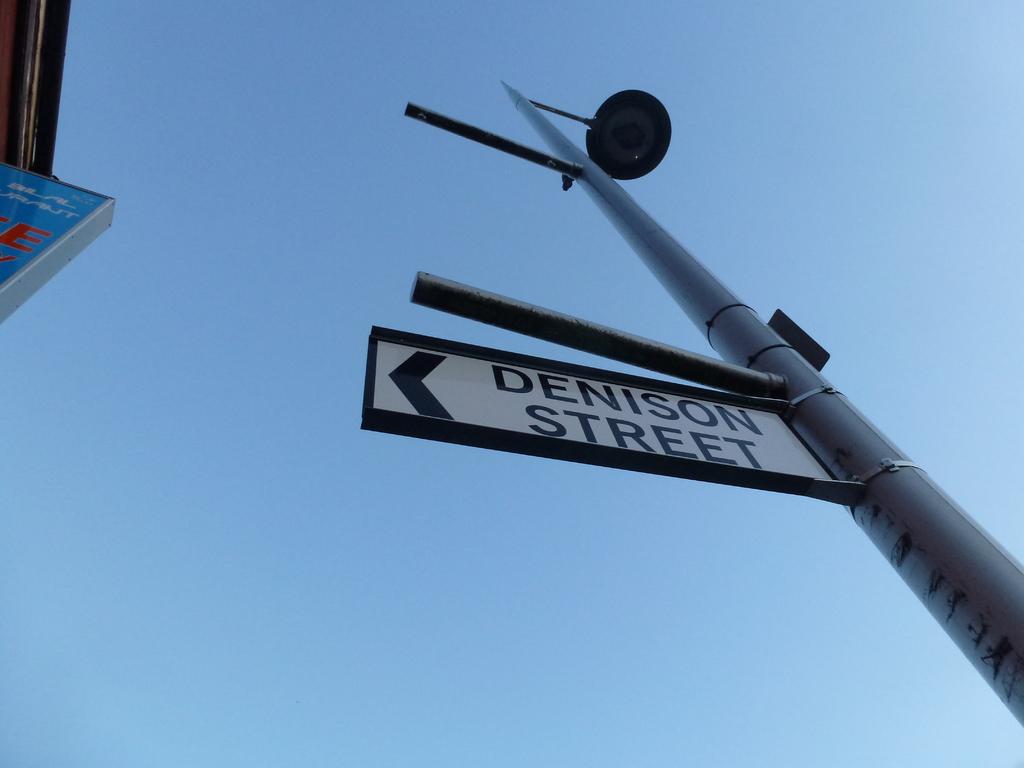What street is this sign on?
Your response must be concise. Denison street. What word is next to the legs?
Offer a very short reply. Unanswerable. 